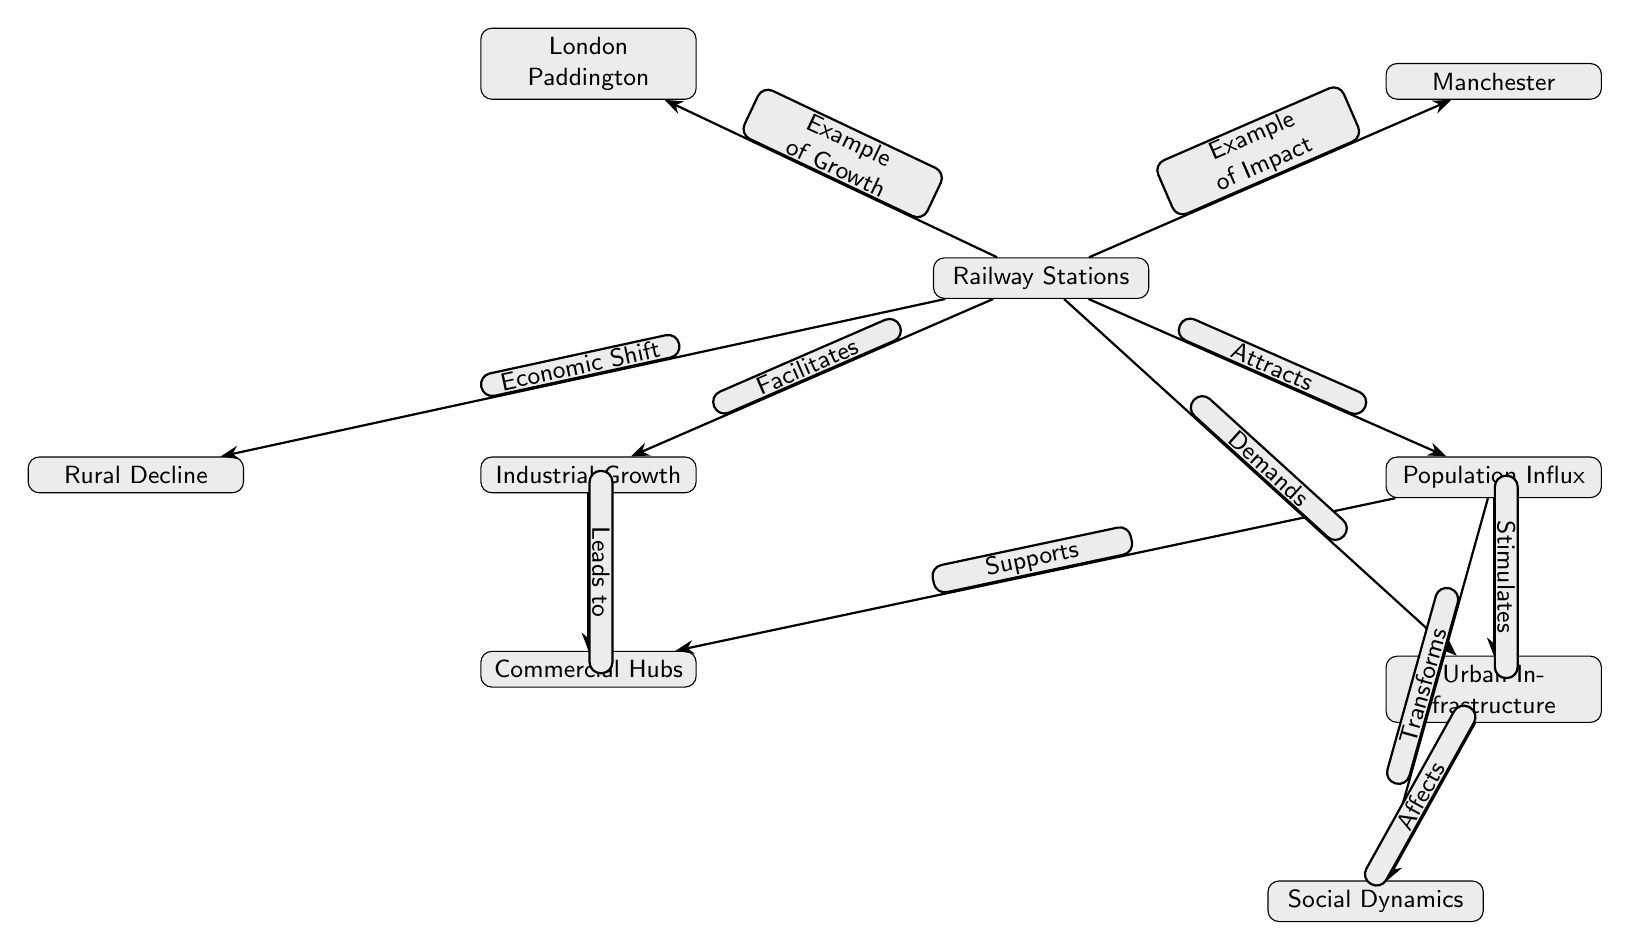What are the main nodes depicted in the diagram? The main nodes shown in the diagram are Railway Stations, Industrial Growth, Population Influx, Urban Infrastructure, Commercial Hubs, London Paddington, Rural Decline, Manchester, and Social Dynamics.
Answer: Railway Stations, Industrial Growth, Population Influx, Urban Infrastructure, Commercial Hubs, London Paddington, Rural Decline, Manchester, Social Dynamics How many edges are present in the diagram? By counting the arrows connecting the nodes, there are a total of 10 edges depicted in the diagram.
Answer: 10 What relationship does "Railway Stations" have with "Industrial Growth"? The edge connecting "Railway Stations" to "Industrial Growth" indicates that the former "Facilitates" the latter, showcasing a direct influence.
Answer: Facilitates What does "Population Influx" stimulate in the diagram? According to the edges, "Population Influx" stimulates "Urban Infrastructure," meaning the increase in population encourages the development of urban facilities.
Answer: Urban Infrastructure How does "Rural Decline" relate to "Railway Stations"? The edge from "Railway Stations" to "Rural Decline" indicates an "Economic Shift," suggesting how the establishment of railways can contribute to a decline in rural areas by attracting resources and population to urban centers.
Answer: Economic Shift What two aspects are affected by "Urban Infrastructure"? The diagram shows that "Urban Infrastructure" affects "Social Dynamics," indicating a relationship where infrastructure development influences social interactions and conditions in urban areas.
Answer: Social Dynamics What nodes are examples of the railway expansion impact? The diagram identifies "London Paddington" and "Manchester" as examples, showcasing specific places that demonstrate the effects of railway expansion.
Answer: London Paddington, Manchester What leads to the development of "Commercial Hubs"? The edge shows that "Industrial Growth" leads to the establishment of "Commercial Hubs," indicating a relationship where industrial activities promote commercial development.
Answer: Leads to Which node is described as being both an example of growth and an example of impact? The node labeled "Railway Stations" serves as both an example of growth through the establishment of railway systems and an impact due to its effects on urban development.
Answer: Railway Stations What is transformed by "Population Influx"? The diagram indicates that "Population Influx" transforms "Social Dynamics," highlighting the influence of increasing population on societal interactions and structures in urban areas.
Answer: Social Dynamics 